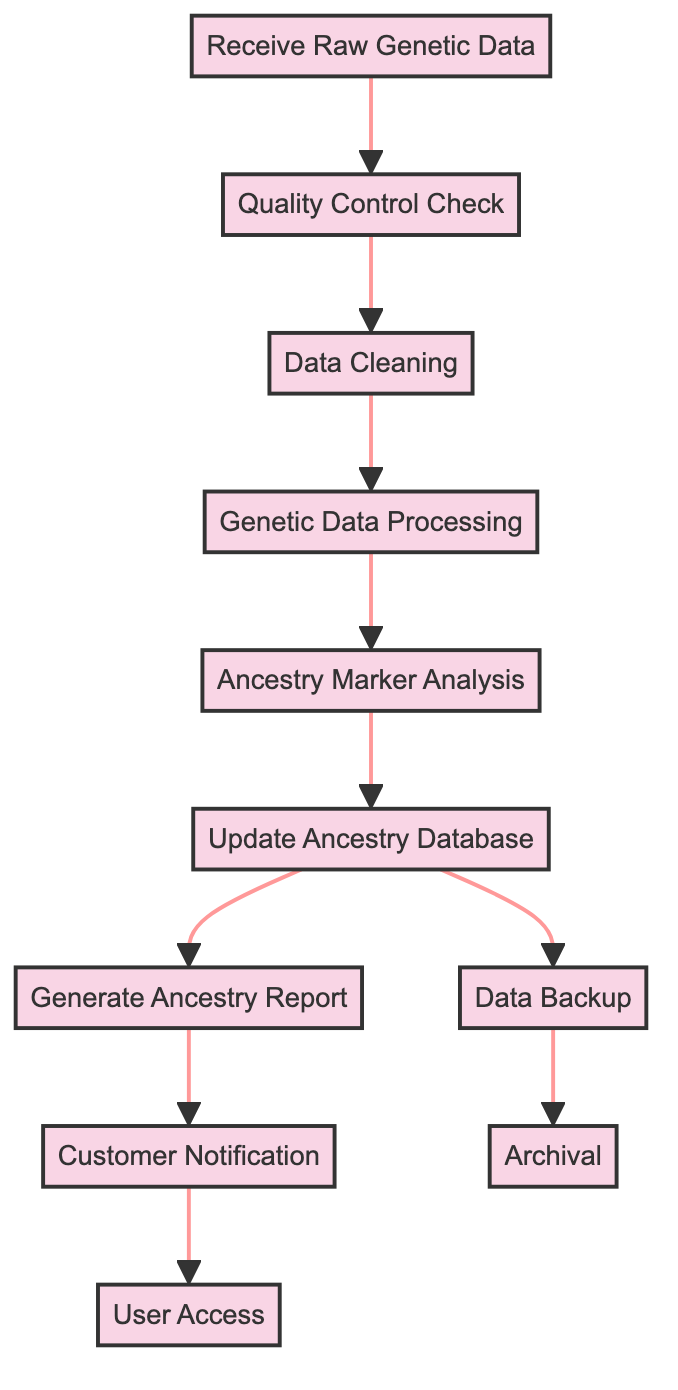What is the first step in the process? The first step is represented by the node labeled "Receive Raw Genetic Data," which is where the process starts.
Answer: Receive Raw Genetic Data How many total process nodes are there in the diagram? Counting the nodes listed, there are a total of 11 process nodes in the diagram.
Answer: 11 What follows the "Ancestry Marker Analysis" step? The step following "Ancestry Marker Analysis" is "Update Ancestry Database," which shows the flow of the process from one analysis to the action of updating the database.
Answer: Update Ancestry Database Which step involves creating backup copies? The step titled "Data Backup" is specifically designated for creating backup copies of the updated database, making it clear where this action occurs.
Answer: Data Backup What is the final action taken after customer notification? After the notification to the customer, the last action in the flow is "User Access," indicating that customers can access their data after being informed.
Answer: User Access What step occurs immediately after the data cleaning phase? The step that occurs immediately after "Data Cleaning" is "Genetic Data Processing," showing a direct progression from cleaning to processing.
Answer: Genetic Data Processing How many paths lead from the "Update Ancestry Database" step? There are two distinct paths that lead from "Update Ancestry Database"—one goes to "Data Backup" and the other to "Generate Ancestry Report."
Answer: 2 What is archived after the data backup? The previous version of the database is archived following the "Data Backup," as indicated in the flow of the diagram.
Answer: Previous version of the database Which nodes are not directly followed by other processes? The nodes "Receive Raw Genetic Data," "Data Backup," and "Customer Notification" do not have subsequent steps directly following them in the flow.
Answer: Receive Raw Genetic Data, Data Backup, Customer Notification Where does the ancestry report generation fit into the process flow? The generation of the ancestry report follows the update of the ancestry database step, indicating it is a direct result of newly processed data.
Answer: After Update Ancestry Database 